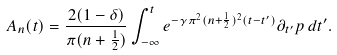<formula> <loc_0><loc_0><loc_500><loc_500>A _ { n } ( t ) = \frac { 2 ( 1 - \delta ) } { \pi ( n + \frac { 1 } { 2 } ) } \int _ { - \infty } ^ { t } e ^ { - \gamma \pi ^ { 2 } ( n + \frac { 1 } { 2 } ) ^ { 2 } ( t - t ^ { \prime } ) } \partial _ { t ^ { \prime } } p \, d t ^ { \prime } .</formula> 